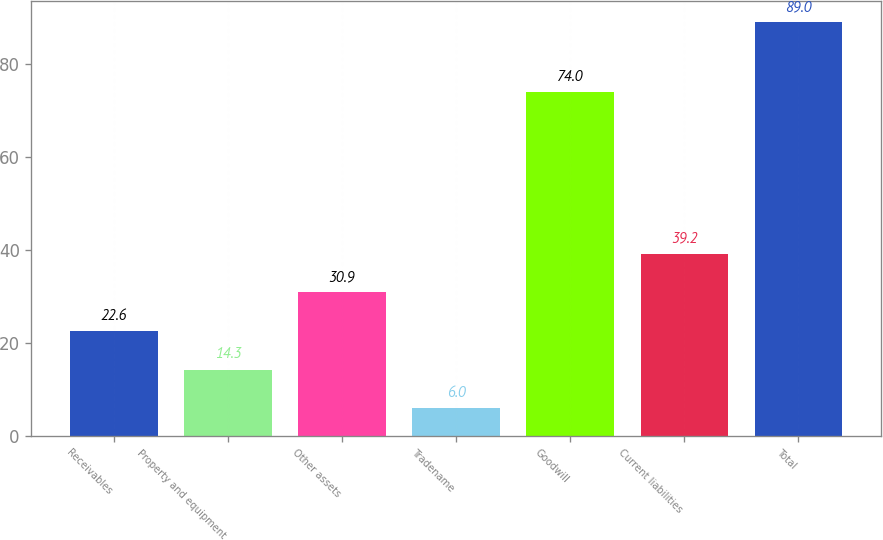Convert chart. <chart><loc_0><loc_0><loc_500><loc_500><bar_chart><fcel>Receivables<fcel>Property and equipment<fcel>Other assets<fcel>Tradename<fcel>Goodwill<fcel>Current liabilities<fcel>Total<nl><fcel>22.6<fcel>14.3<fcel>30.9<fcel>6<fcel>74<fcel>39.2<fcel>89<nl></chart> 